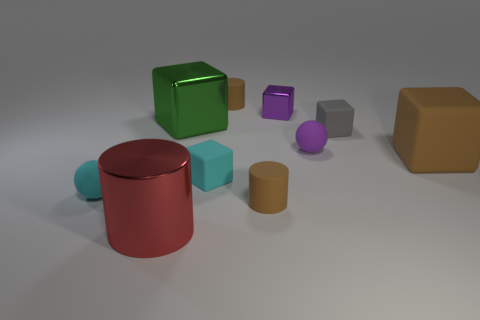What is the size of the matte sphere that is behind the matte block that is left of the gray matte thing?
Your answer should be compact. Small. There is a tiny ball that is behind the tiny cyan block; what is its color?
Your answer should be compact. Purple. Are there any big brown matte objects of the same shape as the tiny shiny thing?
Offer a terse response. Yes. Is the number of shiny blocks that are behind the small cyan matte ball less than the number of brown cylinders that are on the right side of the tiny purple metal thing?
Your response must be concise. No. The big metal block has what color?
Offer a terse response. Green. Are there any small brown matte cylinders behind the tiny brown matte cylinder that is in front of the purple metal thing?
Ensure brevity in your answer.  Yes. What number of purple balls are the same size as the gray object?
Keep it short and to the point. 1. There is a big cube on the left side of the tiny purple object in front of the green block; what number of green objects are behind it?
Provide a succinct answer. 0. What number of rubber things are both left of the cyan block and to the right of the red cylinder?
Provide a short and direct response. 0. Is there anything else that has the same color as the big rubber cube?
Give a very brief answer. Yes. 